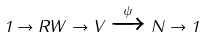Convert formula to latex. <formula><loc_0><loc_0><loc_500><loc_500>1 \to R W \to V \xrightarrow { \psi } N \to 1</formula> 